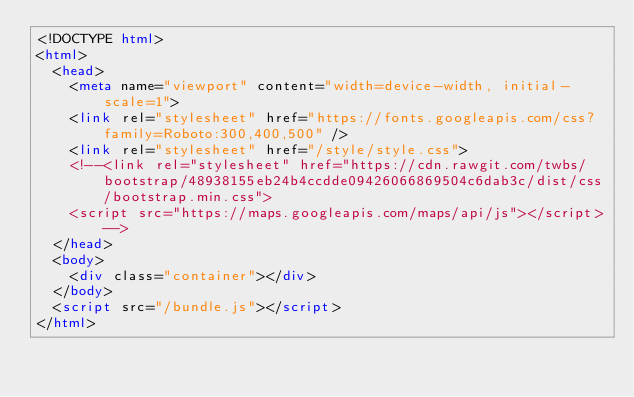Convert code to text. <code><loc_0><loc_0><loc_500><loc_500><_HTML_><!DOCTYPE html>
<html>
  <head>
    <meta name="viewport" content="width=device-width, initial-scale=1">
    <link rel="stylesheet" href="https://fonts.googleapis.com/css?family=Roboto:300,400,500" />
    <link rel="stylesheet" href="/style/style.css">
    <!--<link rel="stylesheet" href="https://cdn.rawgit.com/twbs/bootstrap/48938155eb24b4ccdde09426066869504c6dab3c/dist/css/bootstrap.min.css">
    <script src="https://maps.googleapis.com/maps/api/js"></script>-->
  </head>
  <body>
    <div class="container"></div>
  </body>
  <script src="/bundle.js"></script>
</html>
</code> 